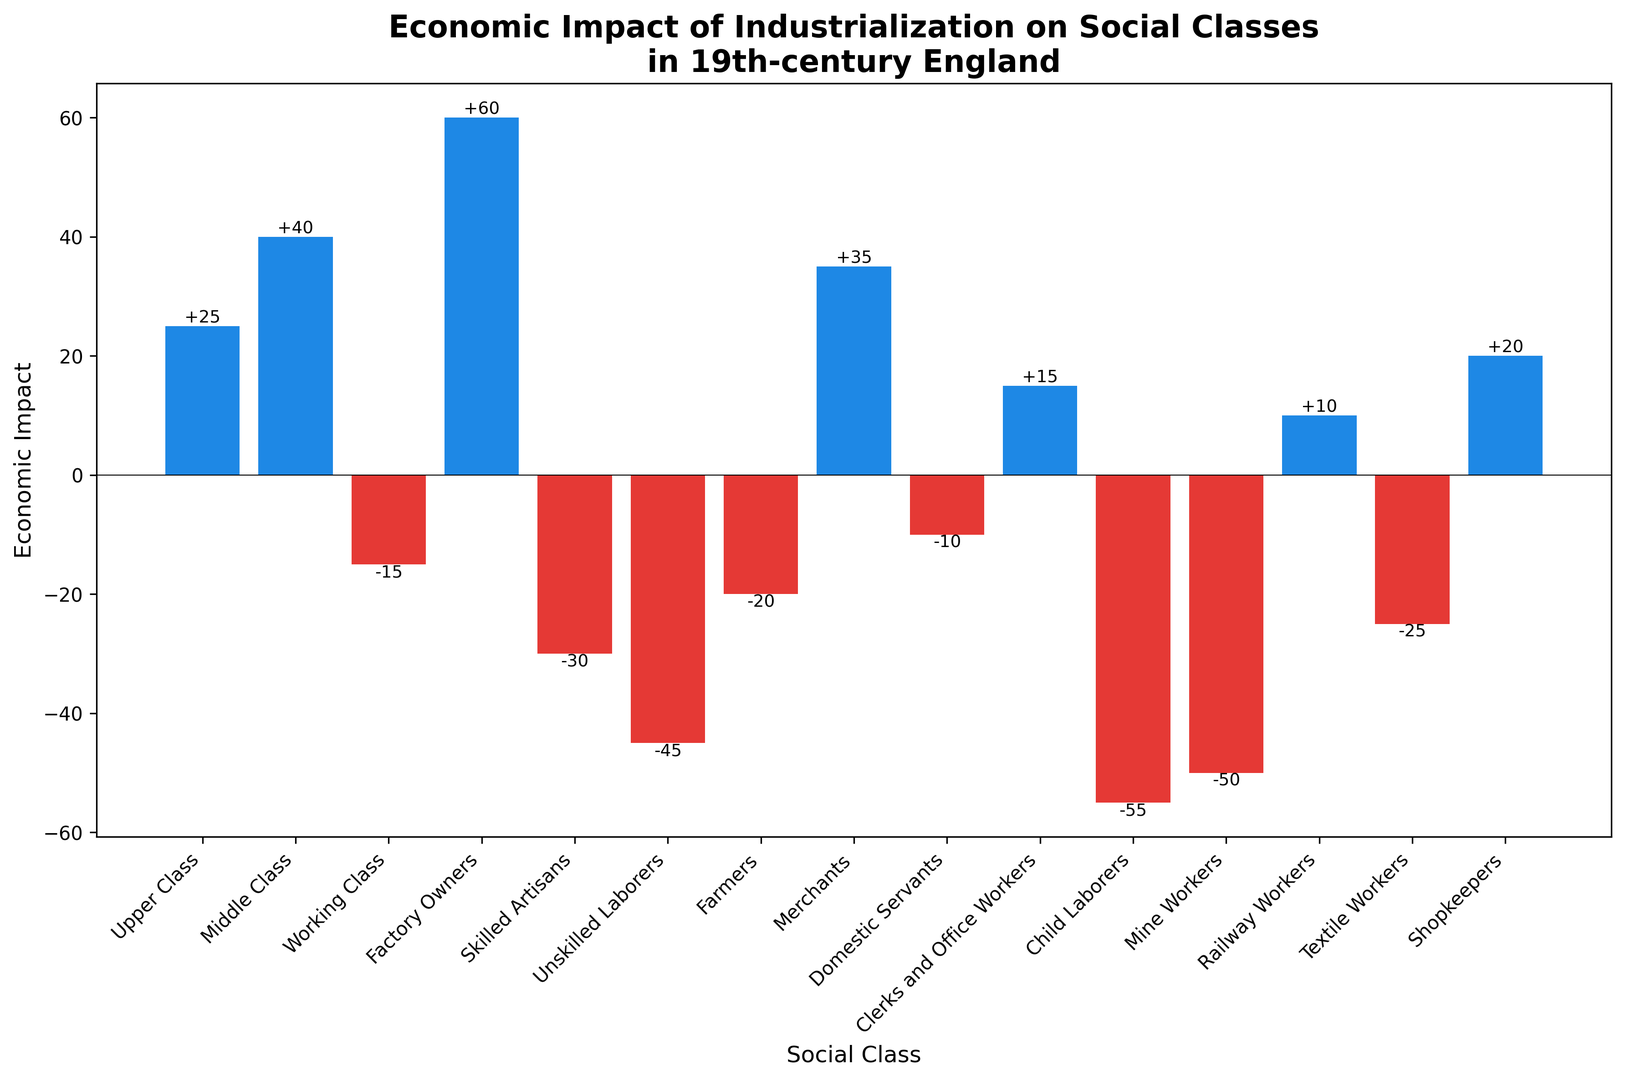Which social class experienced the greatest economic gain during industrialization in 19th-century England? Factory Owners experienced the greatest economic gain. This is evident because the bar representing Factory Owners is the tallest positive bar, indicating the highest positive economic impact.
Answer: Factory Owners Which social class experienced the greatest economic loss? Child Laborers experienced the greatest economic loss. This is evident because the bar representing Child Laborers is the tallest negative bar, indicating the highest negative economic impact.
Answer: Child Laborers What is the total economic impact for the Upper Class, Middle Class, and Merchants combined? To find the total economic impact, we sum the values for the Upper Class, Middle Class, and Merchants. Upper Class (25) + Middle Class (40) + Merchants (35) = 100.
Answer: 100 Which social class experienced a worse economic impact, Mine Workers or Textile Workers? Mine Workers experienced a worse economic impact. The bar representing Mine Workers is lower than the bar representing Textile Workers, indicating a more negative value (-50 vs. -25).
Answer: Mine Workers What is the average economic impact of the social classes with negative values? To find the average economic impact of the social classes with negative values, we need to first sum the negative values and then divide by the number of those classes. The negative values are: -15 (Working Class), -30 (Skilled Artisans), -45 (Unskilled Laborers), -20 (Farmers), -10 (Domestic Servants), -55 (Child Laborers), -50 (Mine Workers), -25 (Textile Workers). Sum = -250. There are 8 classes. So, -250 / 8 = -31.25.
Answer: -31.25 Which social class had a positive economic impact but less than 20? Clerks and Office Workers had a positive economic impact of 15, which is less than 20. This can be seen as the bar reaches just above the zero line but below the 20 mark.
Answer: Clerks and Office Workers Is the economic impact of Clerks and Office Workers upwards or downwards? The economic impact of Clerks and Office Workers is upwards. This is demonstrated by the bar rising above the zero line, indicating a positive economic impact.
Answer: Upwards What is the difference in economic impact between Merchants and Shopkeepers? To determine the difference, we subtract the economic impact of Shopkeepers from that of Merchants. Merchants (35) - Shopkeepers (20) = 15.
Answer: 15 Which social classes experienced an economic impact between -30 and -10 inclusive? The social classes with an economic impact between -30 and -10 are Working Class (-15), Farmers (-20), Domestic Servants (-10), and Textile Workers (-25). This is derived from visually identifying the bars that fall within this range.
Answer: Working Class, Farmers, Domestic Servants, Textile Workers How many social classes experienced a positive economic impact? To find how many social classes experienced a positive economic impact, we count the bars that are above the zero line. These are for Upper Class, Middle Class, Factory Owners, Merchants, Clerks and Office Workers, Railway Workers, and Shopkeepers. Thus, there are 7 social classes with a positive impact.
Answer: 7 